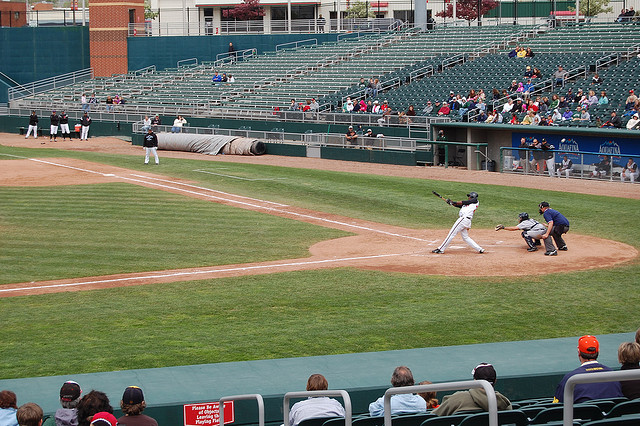What kind of training might these players undergo to prepare for such a game? Baseball players undergo rigorous training to prepare for games. This training is multifaceted and includes:

1. **Physical Conditioning**: This involves strength training, cardiovascular exercises, and flexibility workouts to maintain peak physical fitness.
2. **Skill Drills**: Players practice hitting, pitching, fielding, and base running. Batters take countless swings in batting cages, pitchers work on their control and vary their pitches, and fielders practice catching and throwing techniques.
3. **Scrimmage Games**: Players participate in practice games to simulate real game scenarios. This helps them improve their decision-making and situational awareness.
4. **Mental Training**: Focus and mental toughness are crucial in baseball. Players often work with sports psychologists to develop concentration and resilience strategies.
5. **Diet and Nutrition**: Maintaining a balanced diet and staying hydrated is vital for optimal performance.

Overall, their training is comprehensive, aiming to hone both physical abilities and mental sharpness. 